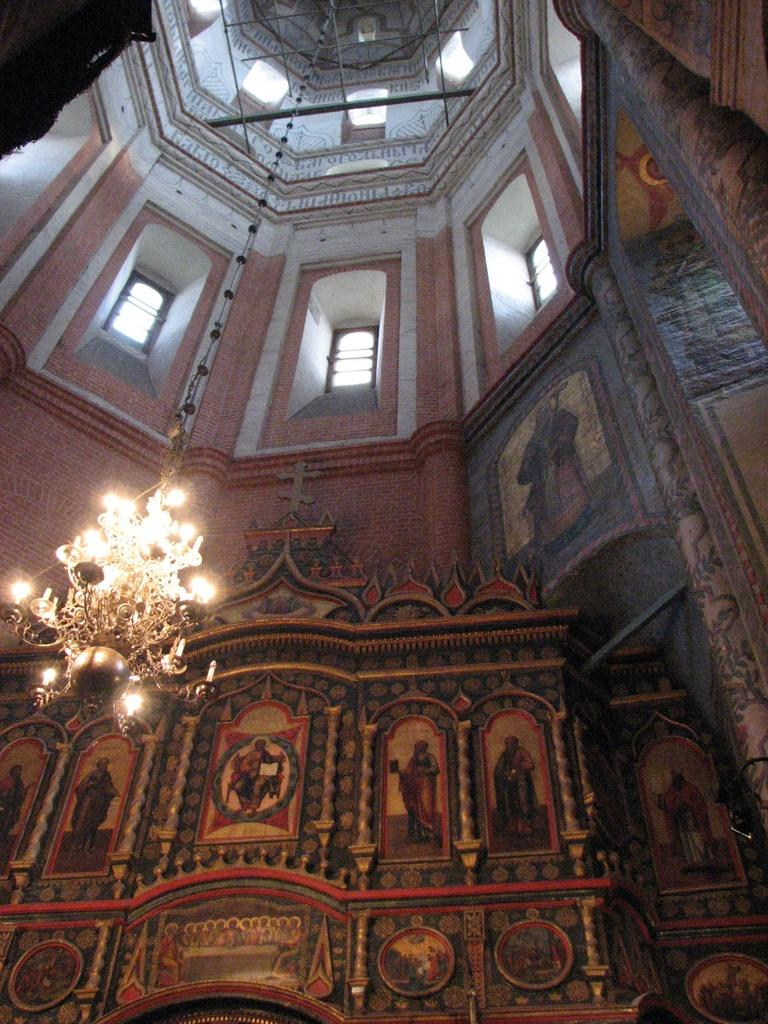Where was the image taken? The image was taken inside a building. What can be seen on the wall in the front of the image? There are arts on the wall in the front of the image. What is hanging from the roof in the middle of the image? There is a light hanging from the roof in the middle of the image. What type of humor can be seen in the image? There is no humor present in the image; it features arts on the wall and a light hanging from the roof. Can you tell me where the zipper is located in the image? There is no zipper present in the image. 